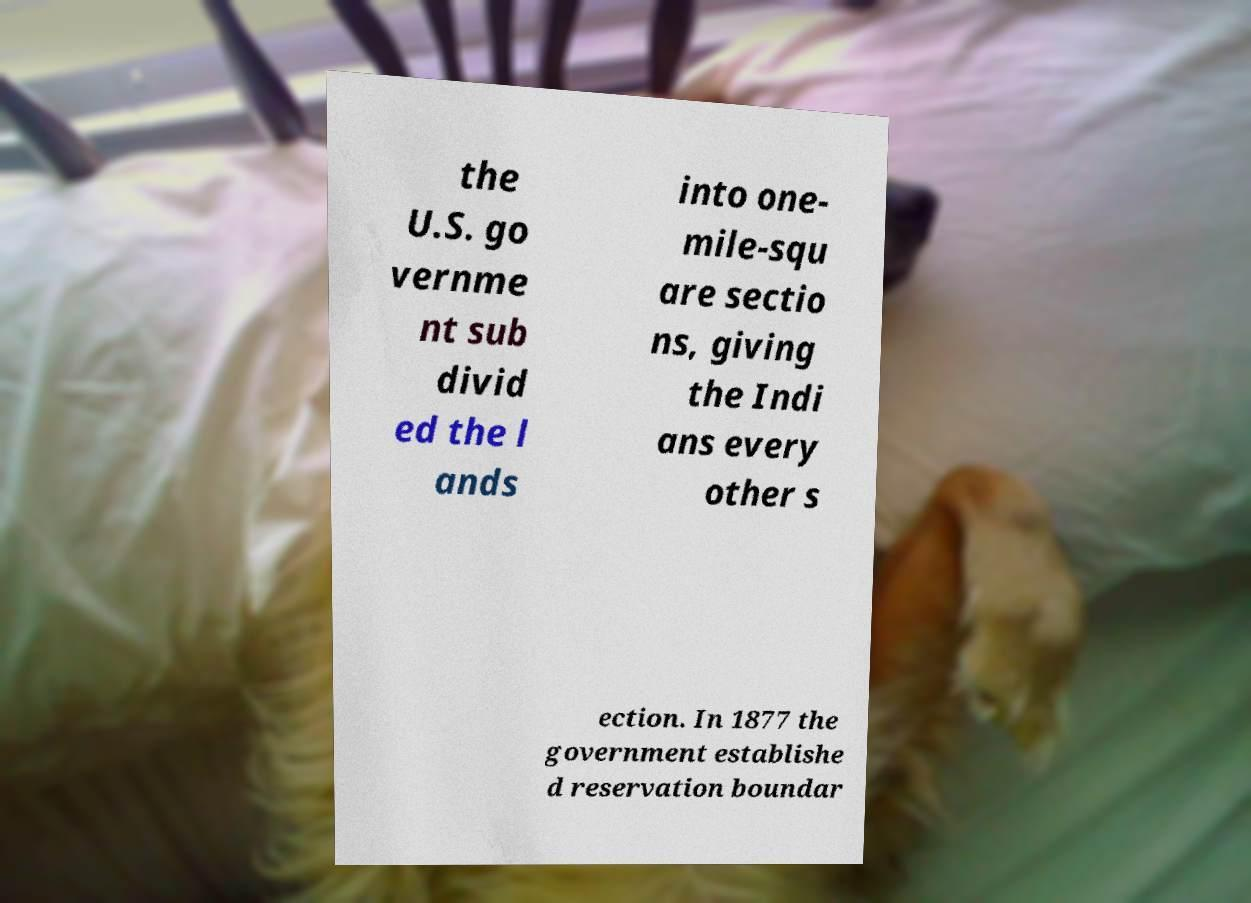There's text embedded in this image that I need extracted. Can you transcribe it verbatim? the U.S. go vernme nt sub divid ed the l ands into one- mile-squ are sectio ns, giving the Indi ans every other s ection. In 1877 the government establishe d reservation boundar 